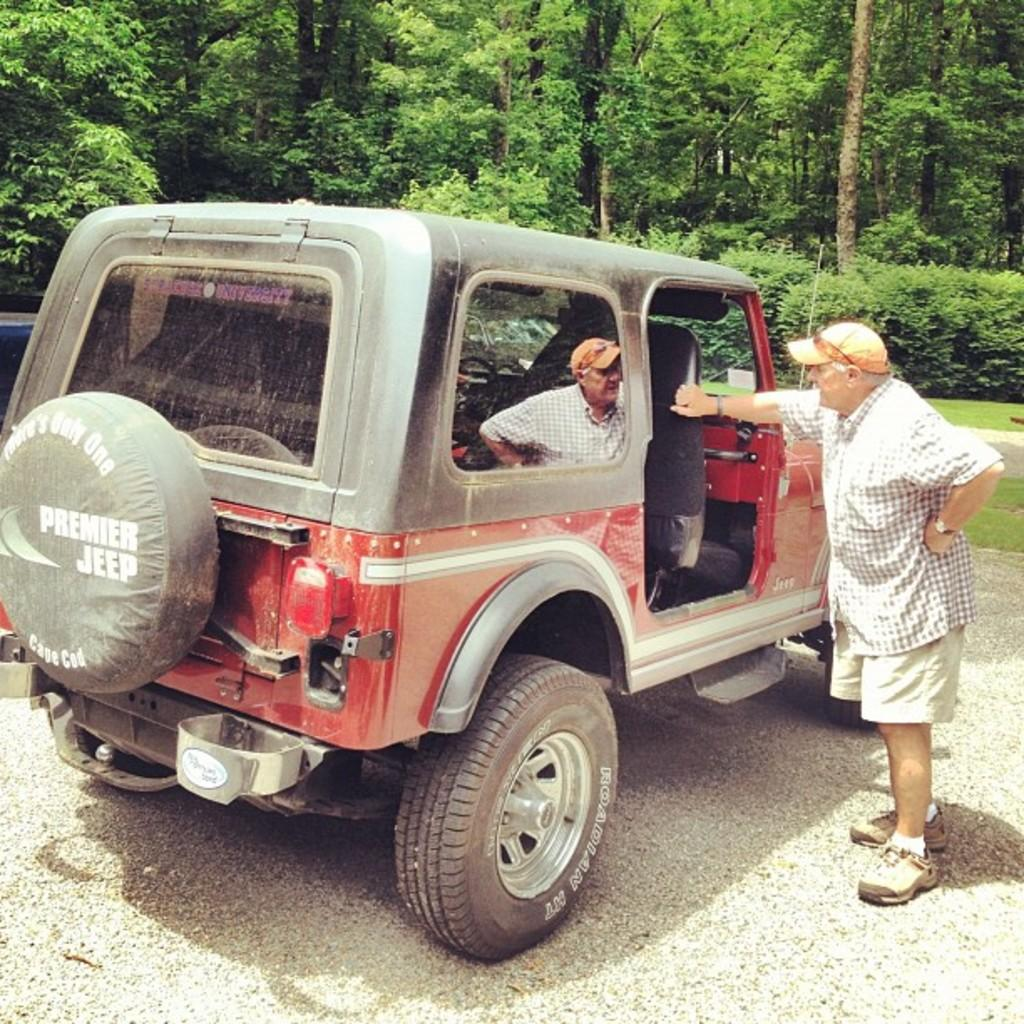What is the main subject in the middle of the picture? There is a jeep vehicle in the middle of the picture. What is the man doing in relation to the jeep? There is a man standing on the side of the jeep. What can be seen in the background of the picture? There are plants and trees in the background of the picture. What is the price of the roll in the image? There is no roll or price mentioned in the image; it features a jeep vehicle and a man standing next to it. 